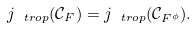Convert formula to latex. <formula><loc_0><loc_0><loc_500><loc_500>j _ { \ t r o p } ( \mathcal { C } _ { F } ) = j _ { \ t r o p } ( \mathcal { C } _ { F ^ { \phi } } ) .</formula> 